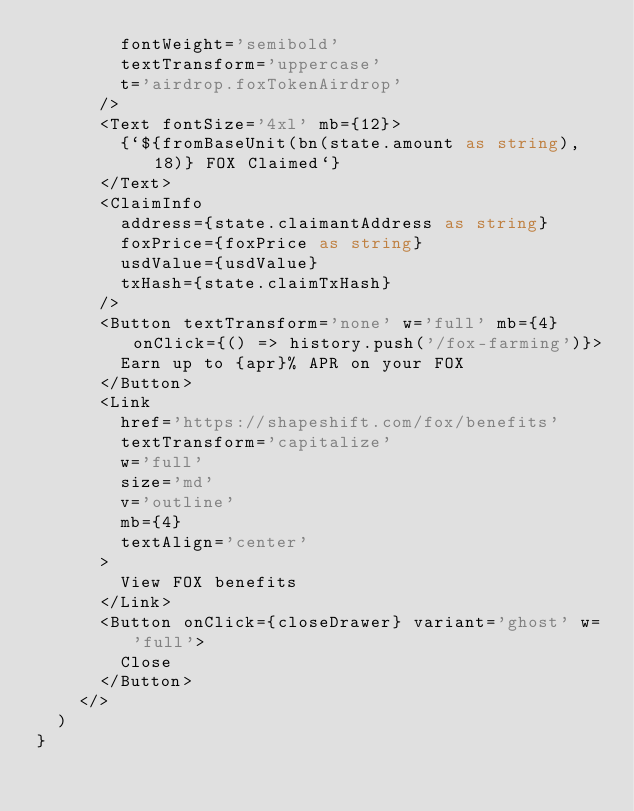<code> <loc_0><loc_0><loc_500><loc_500><_TypeScript_>        fontWeight='semibold'
        textTransform='uppercase'
        t='airdrop.foxTokenAirdrop'
      />
      <Text fontSize='4xl' mb={12}>
        {`${fromBaseUnit(bn(state.amount as string), 18)} FOX Claimed`}
      </Text>
      <ClaimInfo
        address={state.claimantAddress as string}
        foxPrice={foxPrice as string}
        usdValue={usdValue}
        txHash={state.claimTxHash}
      />
      <Button textTransform='none' w='full' mb={4} onClick={() => history.push('/fox-farming')}>
        Earn up to {apr}% APR on your FOX
      </Button>
      <Link
        href='https://shapeshift.com/fox/benefits'
        textTransform='capitalize'
        w='full'
        size='md'
        v='outline'
        mb={4}
        textAlign='center'
      >
        View FOX benefits
      </Link>
      <Button onClick={closeDrawer} variant='ghost' w='full'>
        Close
      </Button>
    </>
  )
}
</code> 